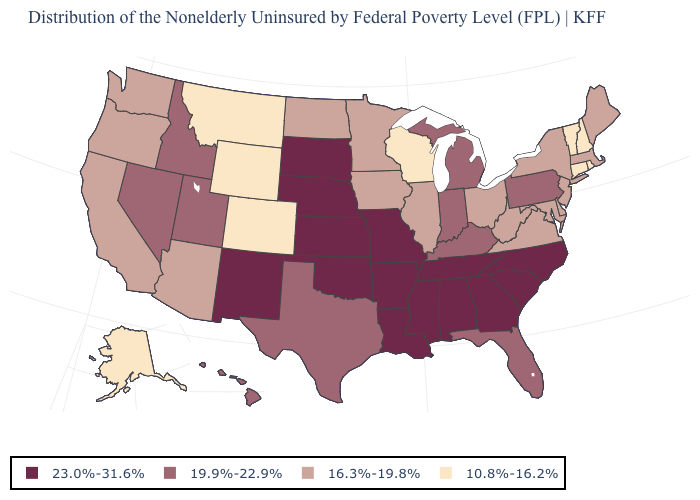How many symbols are there in the legend?
Keep it brief. 4. What is the value of Connecticut?
Give a very brief answer. 10.8%-16.2%. What is the value of South Dakota?
Answer briefly. 23.0%-31.6%. What is the value of Ohio?
Give a very brief answer. 16.3%-19.8%. Does Texas have the same value as Arizona?
Answer briefly. No. Name the states that have a value in the range 23.0%-31.6%?
Quick response, please. Alabama, Arkansas, Georgia, Kansas, Louisiana, Mississippi, Missouri, Nebraska, New Mexico, North Carolina, Oklahoma, South Carolina, South Dakota, Tennessee. What is the value of Nebraska?
Answer briefly. 23.0%-31.6%. What is the value of Maine?
Concise answer only. 16.3%-19.8%. Name the states that have a value in the range 19.9%-22.9%?
Give a very brief answer. Florida, Hawaii, Idaho, Indiana, Kentucky, Michigan, Nevada, Pennsylvania, Texas, Utah. Does Rhode Island have the lowest value in the USA?
Concise answer only. Yes. What is the lowest value in the USA?
Give a very brief answer. 10.8%-16.2%. What is the value of New Hampshire?
Keep it brief. 10.8%-16.2%. Which states have the highest value in the USA?
Write a very short answer. Alabama, Arkansas, Georgia, Kansas, Louisiana, Mississippi, Missouri, Nebraska, New Mexico, North Carolina, Oklahoma, South Carolina, South Dakota, Tennessee. Name the states that have a value in the range 16.3%-19.8%?
Short answer required. Arizona, California, Delaware, Illinois, Iowa, Maine, Maryland, Massachusetts, Minnesota, New Jersey, New York, North Dakota, Ohio, Oregon, Virginia, Washington, West Virginia. Does West Virginia have the highest value in the South?
Give a very brief answer. No. 